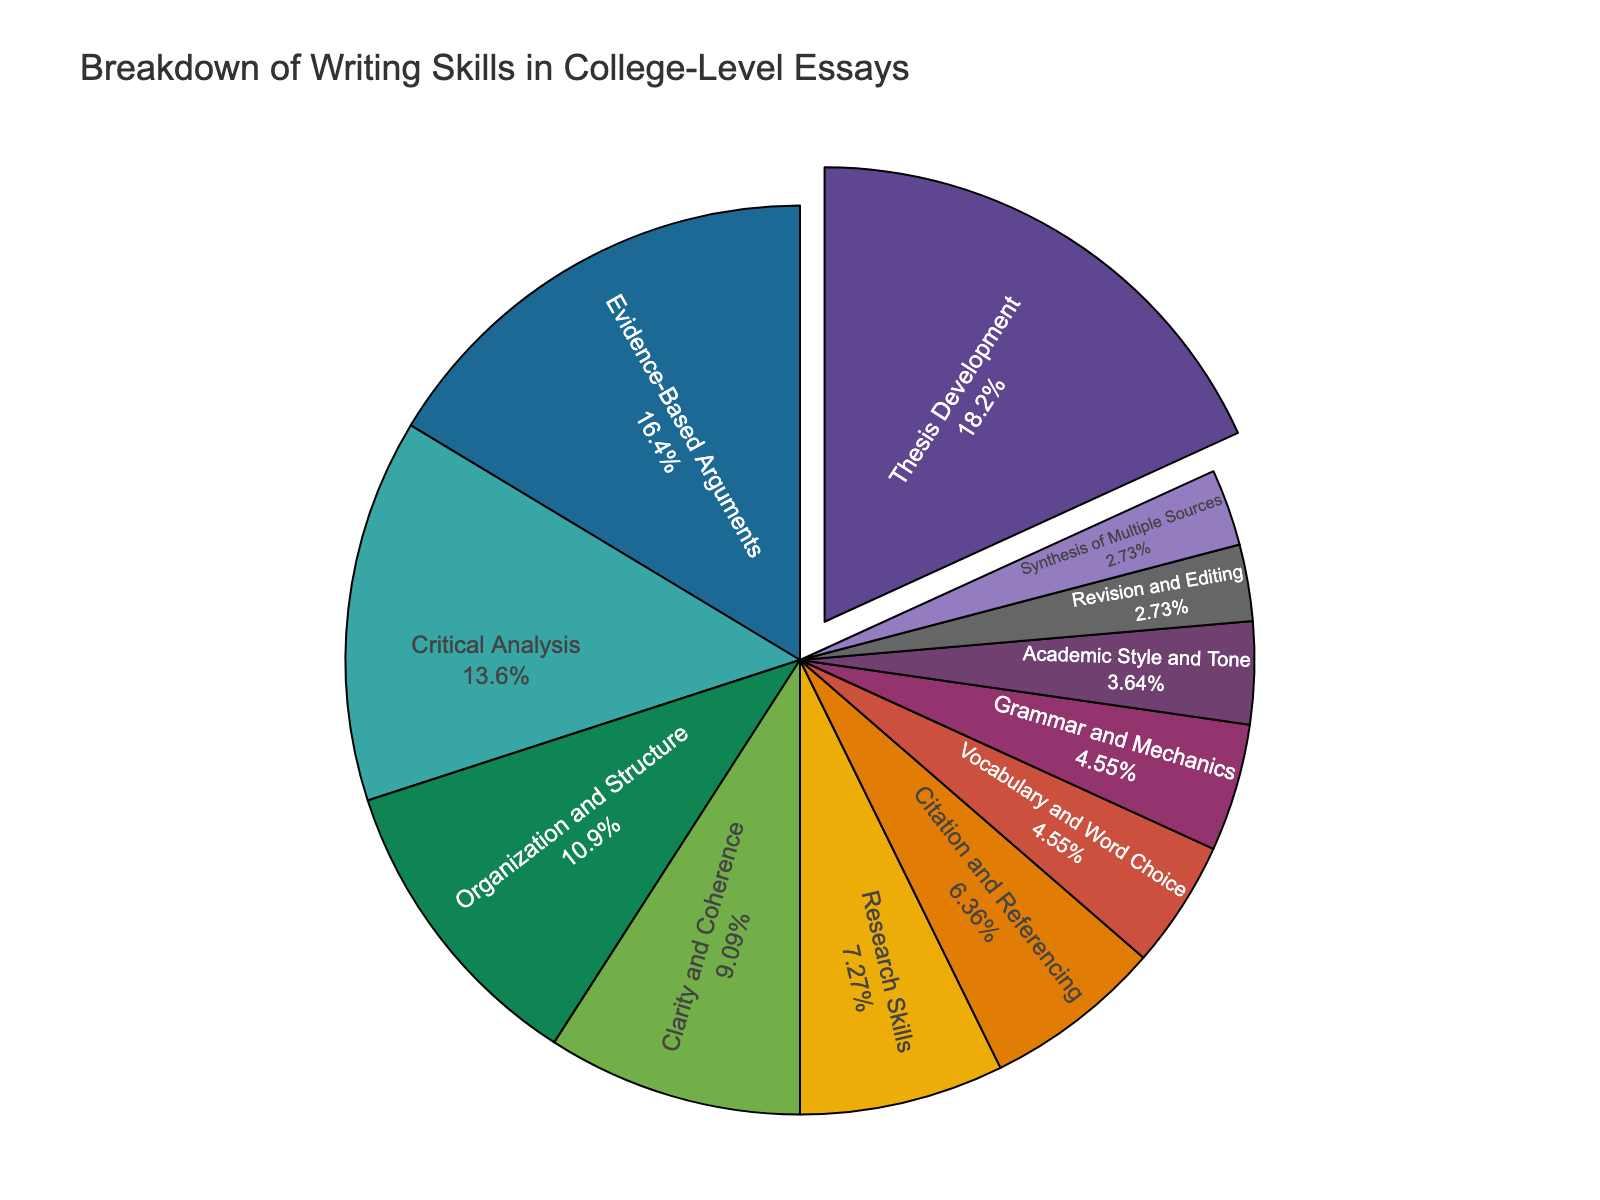What skill has the highest percentage in the breakdown? The figure shows different segments representing various skills with their associated percentages. The segment with the highest percentage is the largest one.
Answer: Thesis Development Which two skills together make up exactly 10% of the total breakdown? To find two skills that together constitute 10%, look for two segments whose individual percentages sum to 10%. The segments for Vocabulary and Word Choice and Grammar and Mechanics each represent 5%.
Answer: Vocabulary and Word Choice, Grammar and Mechanics Is there any skill with a percentage less than 4%? Which skill is it? Look for the segments with the smallest portions in the figure. The pie chart segment for Academic Style and Tone, Revision and Editing, and Synthesis of Multiple Sources are each 3% and 4%.
Answer: Revision and Editing, Synthesis of Multiple Sources What's the combined percentage of Research Skills, Citation and Referencing, and Academic Style and Tone? Sum up the percentages of Research Skills (8%), Citation and Referencing (7%), and Academic Style and Tone (4%). 8% + 7% + 4% = 19%
Answer: 19% Which skill has the largest segment pulled out from the pie chart? The figure shows that the largest segment pulled out is the one with the highest percentage. The outer pulled segment represents Thesis Development.
Answer: Thesis Development How does the percentage of Critical Analysis compare to that of Thesis Development? Compare the segments representing Critical Analysis and Thesis Development. Thesis Development has a larger percentage (20%), while Critical Analysis has 15%.
Answer: Critical Analysis is less than Thesis Development What is the total percentage contribution of Organization and Structure, Clarity and Coherence, and Vocabulary and Word Choice combined? Adding the percentages of Organization and Structure (12%), Clarity and Coherence (10%), and Vocabulary and Word Choice (5%) gives: 12% + 10% + 5% = 27%.
Answer: 27% Which skill occupies the smallest portion of the pie chart? Identify the segment with the smallest percentage. The segment for Revision and Editing and Synthesis of Multiple Sources represents the smallest portion, each with 3%.
Answer: Revision and Editing, Synthesis of Multiple Sources 